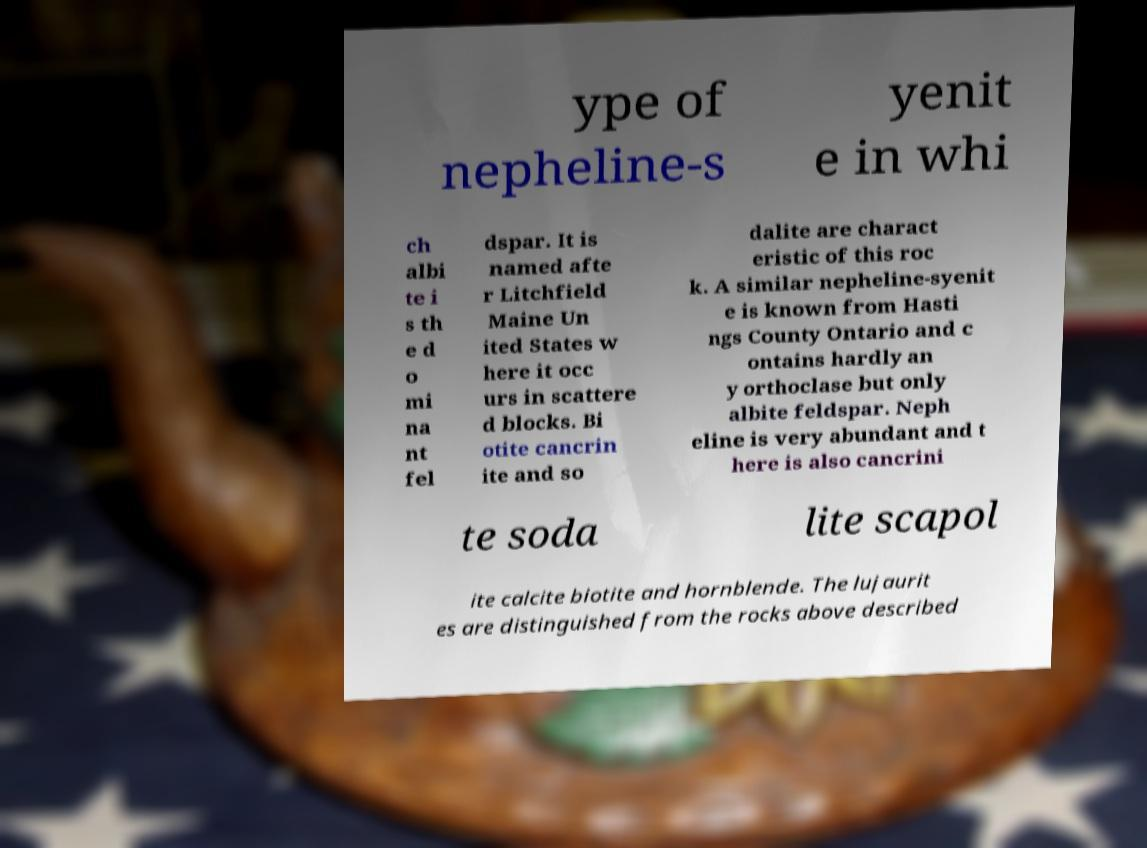Please identify and transcribe the text found in this image. ype of nepheline-s yenit e in whi ch albi te i s th e d o mi na nt fel dspar. It is named afte r Litchfield Maine Un ited States w here it occ urs in scattere d blocks. Bi otite cancrin ite and so dalite are charact eristic of this roc k. A similar nepheline-syenit e is known from Hasti ngs County Ontario and c ontains hardly an y orthoclase but only albite feldspar. Neph eline is very abundant and t here is also cancrini te soda lite scapol ite calcite biotite and hornblende. The lujaurit es are distinguished from the rocks above described 